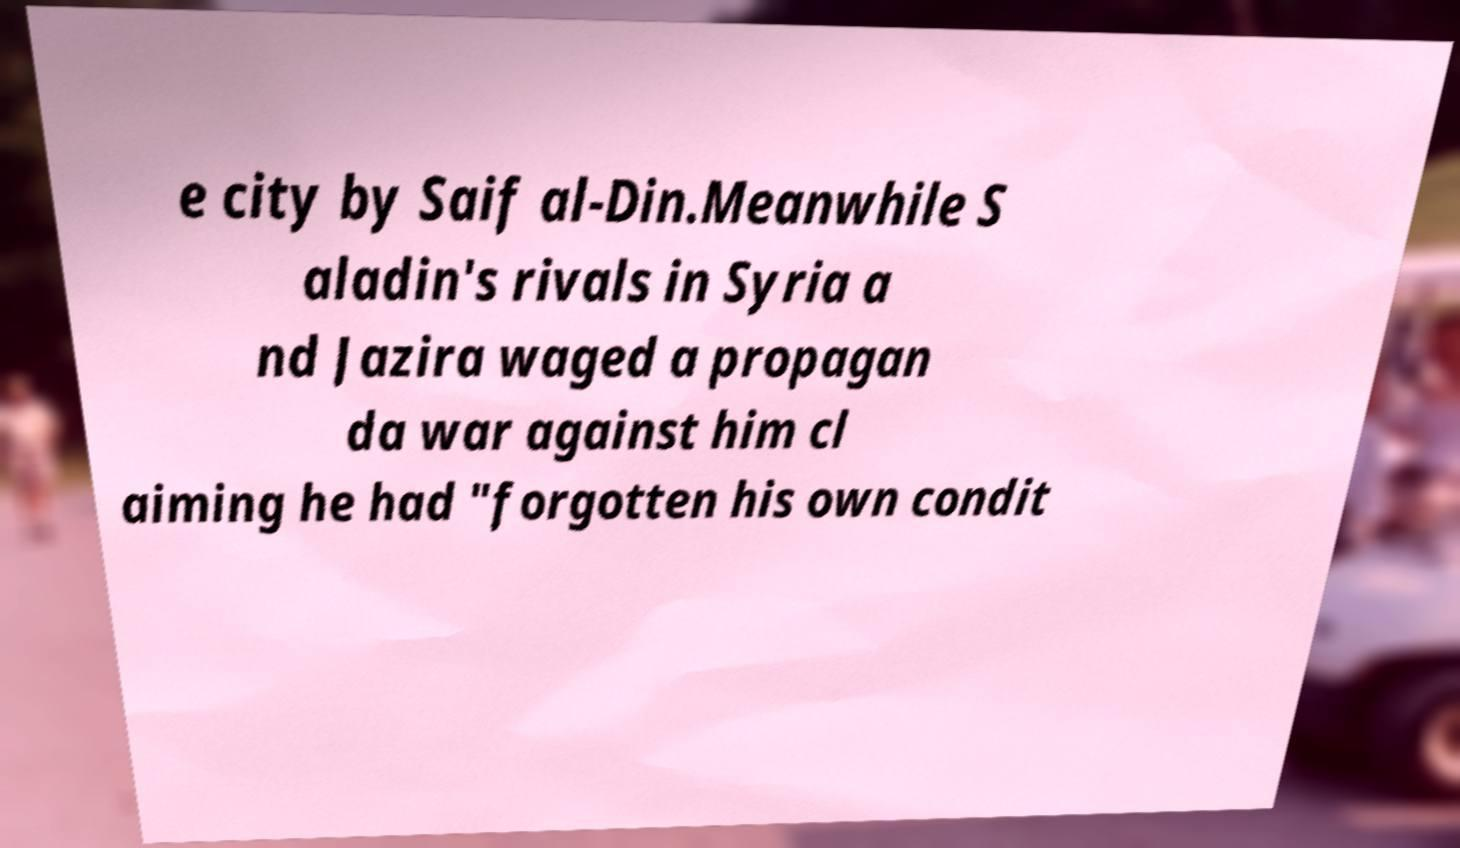Please read and relay the text visible in this image. What does it say? e city by Saif al-Din.Meanwhile S aladin's rivals in Syria a nd Jazira waged a propagan da war against him cl aiming he had "forgotten his own condit 